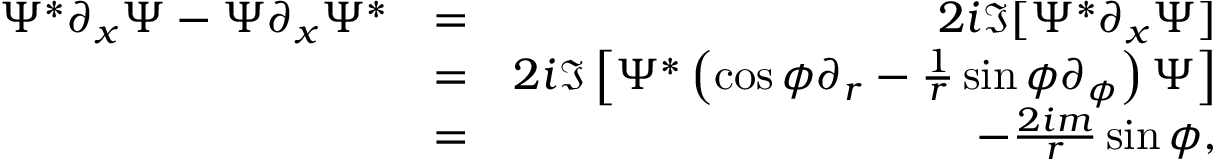<formula> <loc_0><loc_0><loc_500><loc_500>\begin{array} { r l r } { \Psi ^ { * } \partial _ { x } \Psi - \Psi \partial _ { x } \Psi ^ { * } } & { = } & { 2 i \Im [ \Psi ^ { * } \partial _ { x } \Psi ] } \\ & { = } & { 2 i \Im \left [ \Psi ^ { * } \left ( \cos \phi \partial _ { r } - \frac { 1 } { r } \sin \phi \partial _ { \phi } \right ) \Psi \right ] } \\ & { = } & { - \frac { 2 i m } { r } \sin \phi , } \end{array}</formula> 